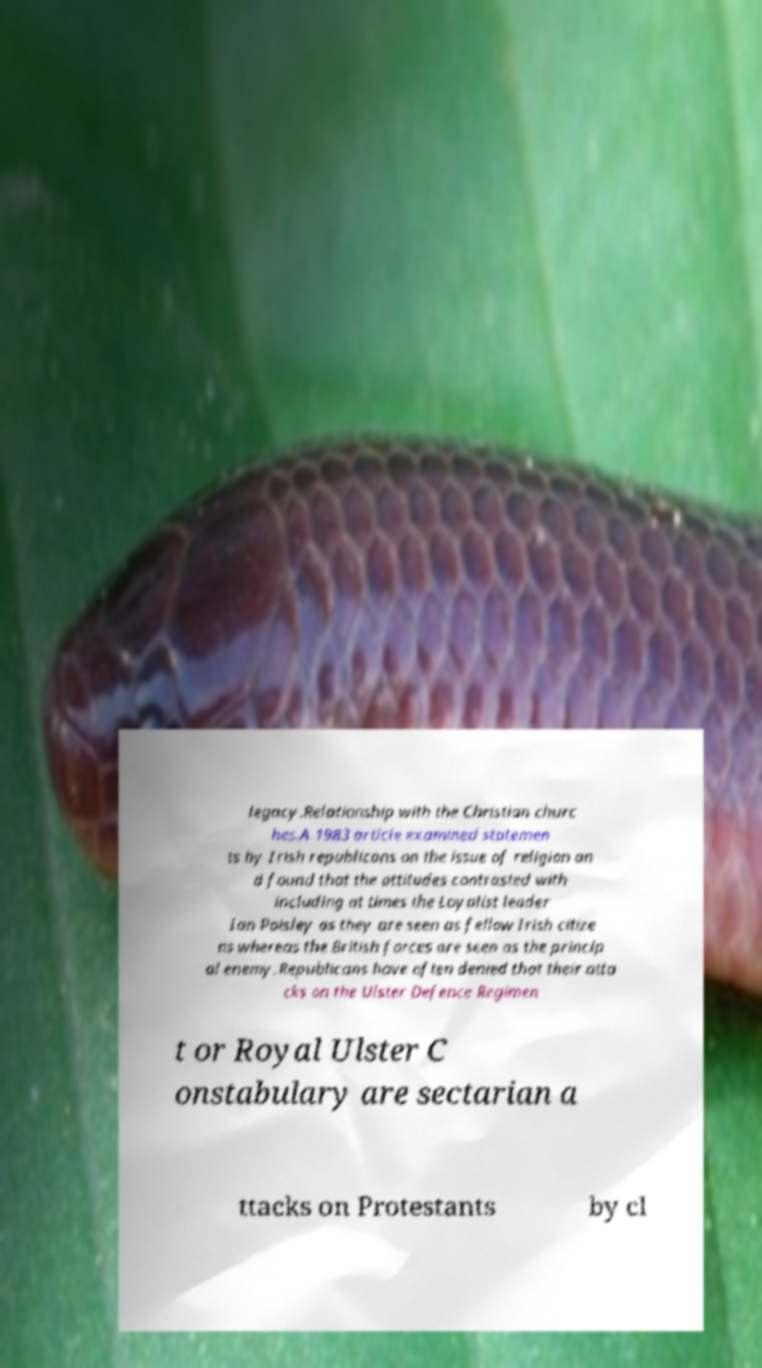Please read and relay the text visible in this image. What does it say? legacy.Relationship with the Christian churc hes.A 1983 article examined statemen ts by Irish republicans on the issue of religion an d found that the attitudes contrasted with including at times the Loyalist leader Ian Paisley as they are seen as fellow Irish citize ns whereas the British forces are seen as the princip al enemy.Republicans have often denied that their atta cks on the Ulster Defence Regimen t or Royal Ulster C onstabulary are sectarian a ttacks on Protestants by cl 